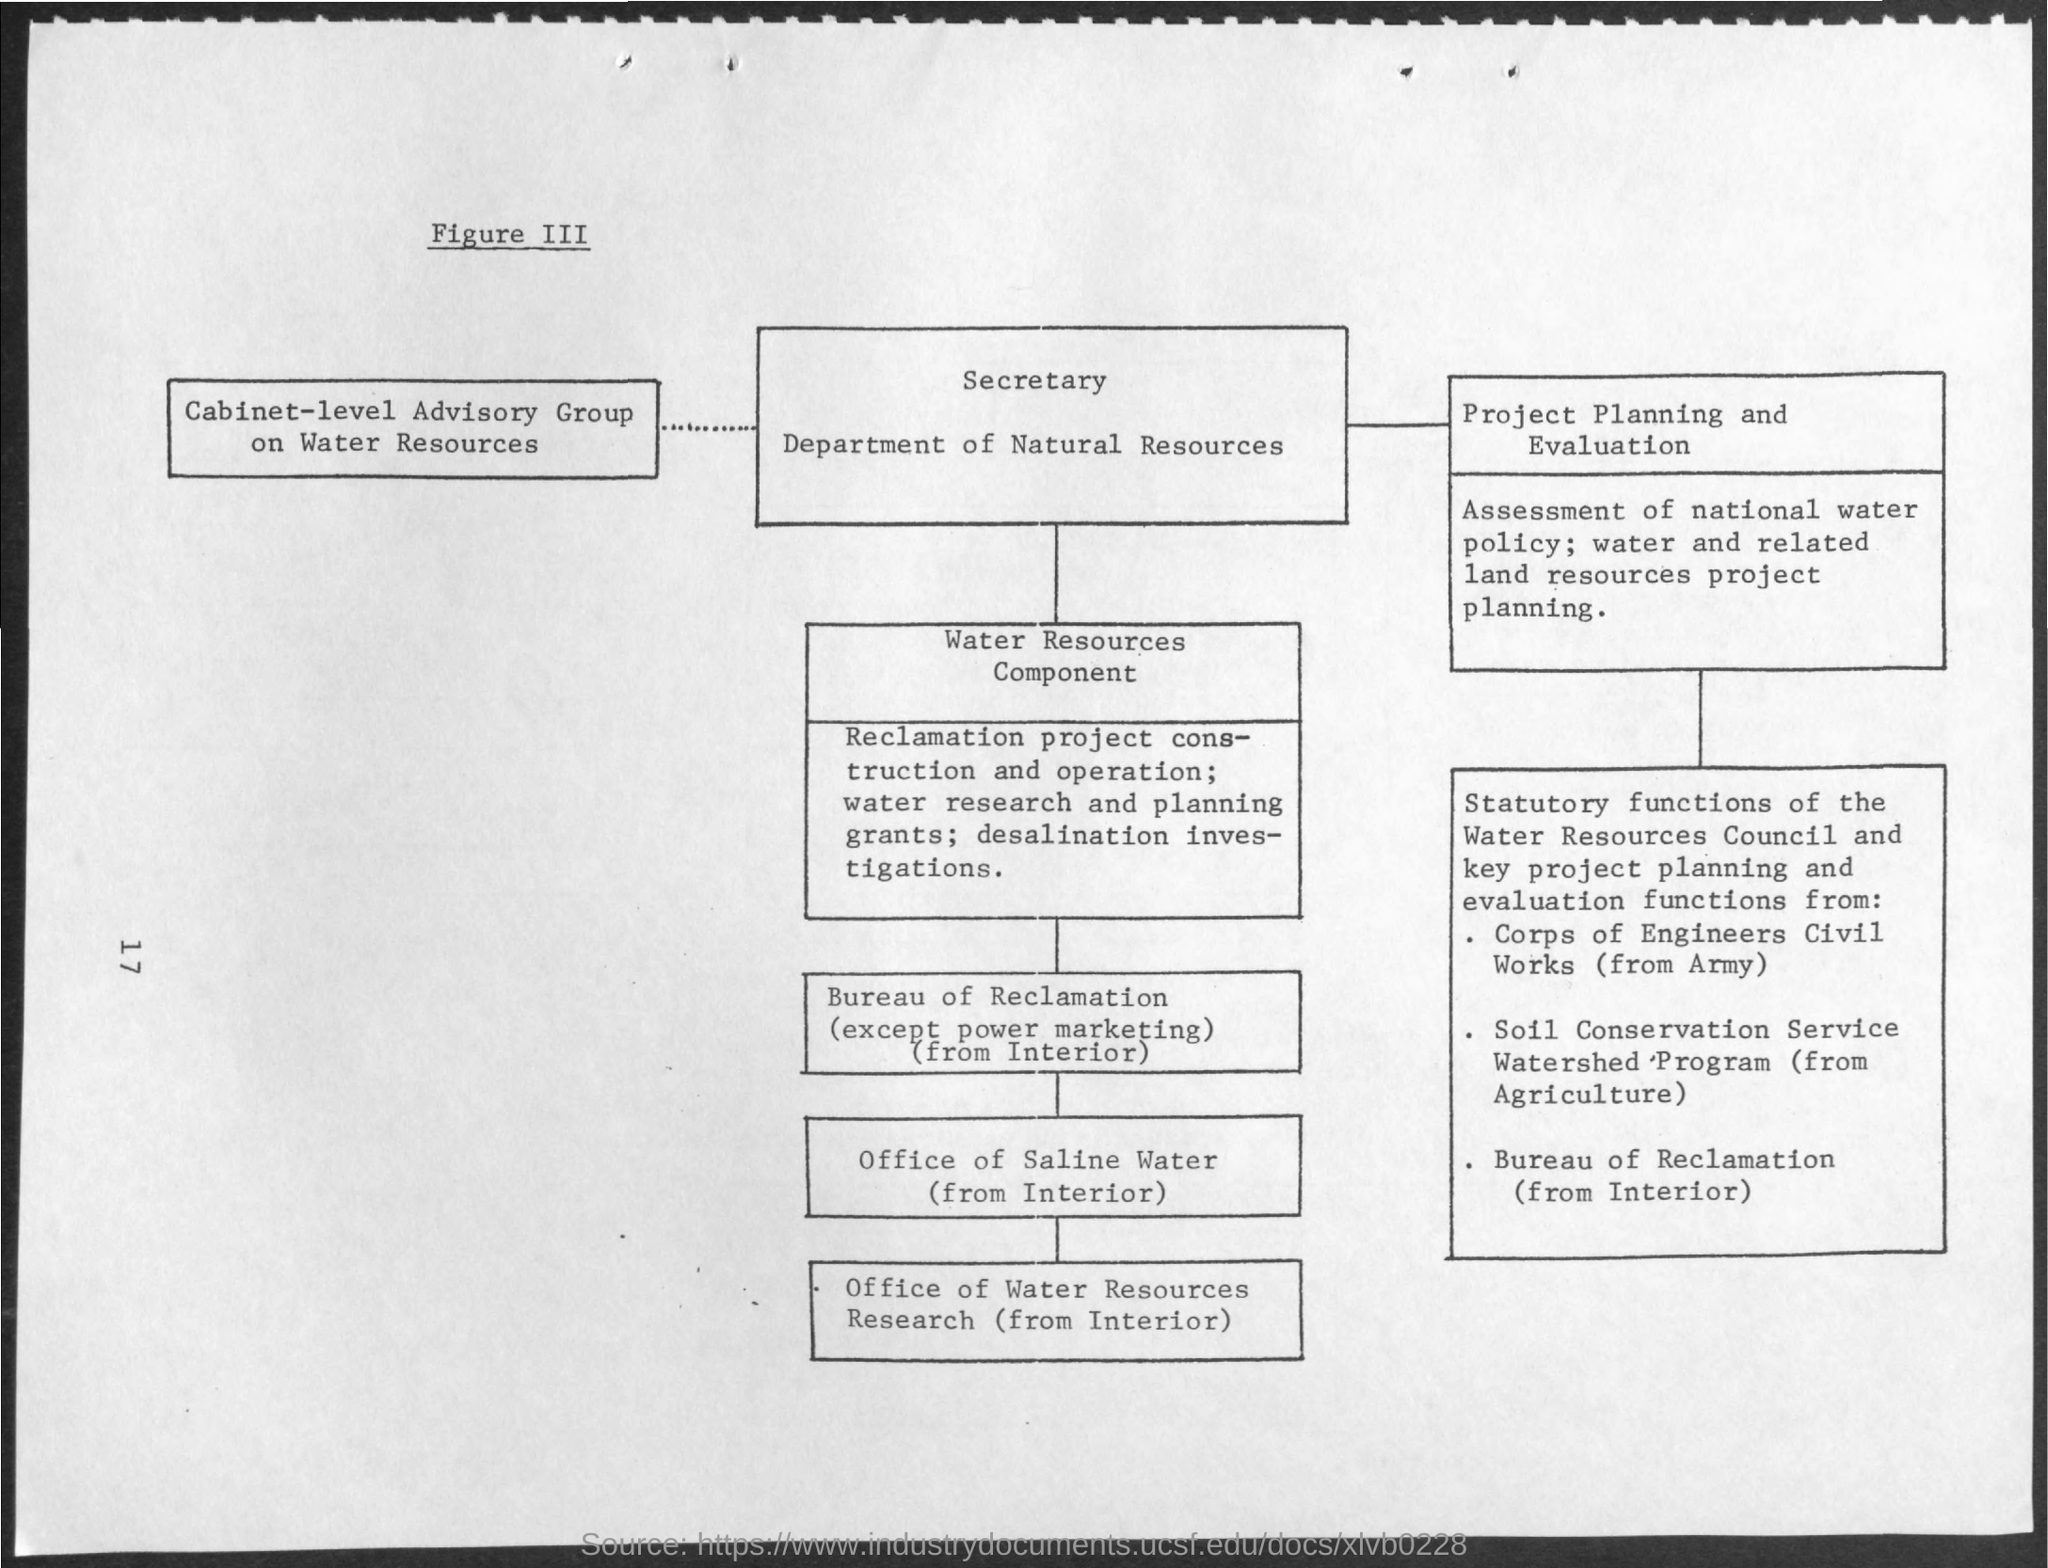What is the Page Number?
Keep it short and to the point. 17. What is the figure number?
Offer a terse response. Iii. 